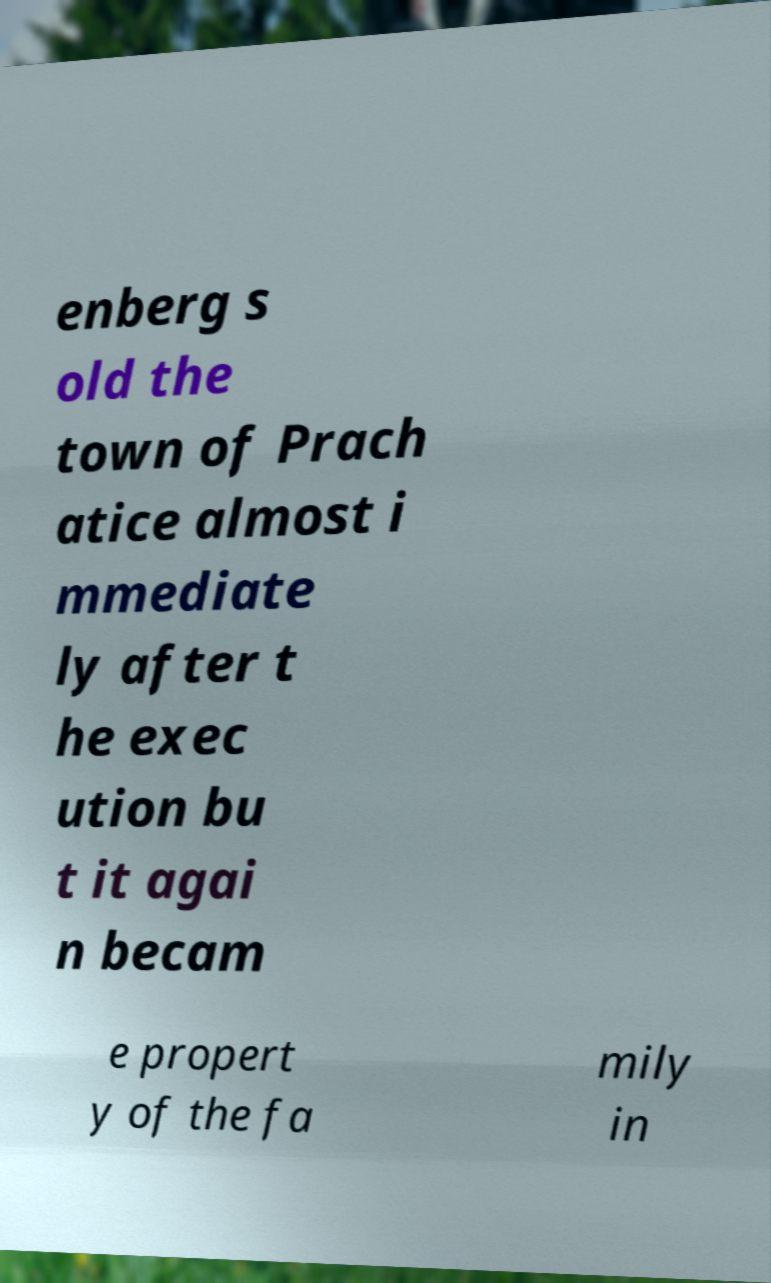Could you assist in decoding the text presented in this image and type it out clearly? enberg s old the town of Prach atice almost i mmediate ly after t he exec ution bu t it agai n becam e propert y of the fa mily in 